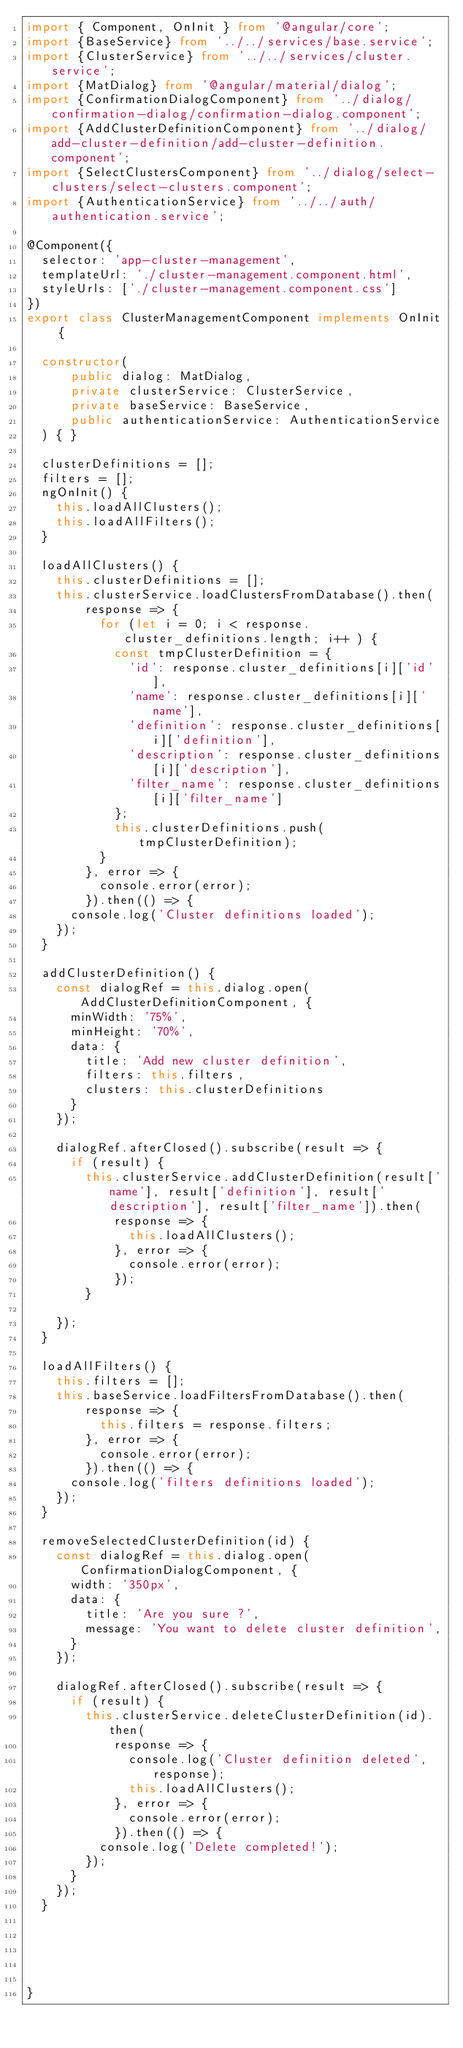<code> <loc_0><loc_0><loc_500><loc_500><_TypeScript_>import { Component, OnInit } from '@angular/core';
import {BaseService} from '../../services/base.service';
import {ClusterService} from '../../services/cluster.service';
import {MatDialog} from '@angular/material/dialog';
import {ConfirmationDialogComponent} from '../dialog/confirmation-dialog/confirmation-dialog.component';
import {AddClusterDefinitionComponent} from '../dialog/add-cluster-definition/add-cluster-definition.component';
import {SelectClustersComponent} from '../dialog/select-clusters/select-clusters.component';
import {AuthenticationService} from '../../auth/authentication.service';

@Component({
  selector: 'app-cluster-management',
  templateUrl: './cluster-management.component.html',
  styleUrls: ['./cluster-management.component.css']
})
export class ClusterManagementComponent implements OnInit {

  constructor(
      public dialog: MatDialog,
      private clusterService: ClusterService,
      private baseService: BaseService,
      public authenticationService: AuthenticationService
  ) { }

  clusterDefinitions = [];
  filters = [];
  ngOnInit() {
    this.loadAllClusters();
    this.loadAllFilters();
  }

  loadAllClusters() {
    this.clusterDefinitions = [];
    this.clusterService.loadClustersFromDatabase().then(
        response => {
          for (let i = 0; i < response.cluster_definitions.length; i++ ) {
            const tmpClusterDefinition = {
              'id': response.cluster_definitions[i]['id'],
              'name': response.cluster_definitions[i]['name'],
              'definition': response.cluster_definitions[i]['definition'],
              'description': response.cluster_definitions[i]['description'],
              'filter_name': response.cluster_definitions[i]['filter_name']
            };
            this.clusterDefinitions.push(tmpClusterDefinition);
          }
        }, error => {
          console.error(error);
        }).then(() => {
      console.log('Cluster definitions loaded');
    });
  }

  addClusterDefinition() {
    const dialogRef = this.dialog.open(AddClusterDefinitionComponent, {
      minWidth: '75%',
      minHeight: '70%',
      data: {
        title: 'Add new cluster definition',
        filters: this.filters,
        clusters: this.clusterDefinitions
      }
    });

    dialogRef.afterClosed().subscribe(result => {
      if (result) {
        this.clusterService.addClusterDefinition(result['name'], result['definition'], result['description'], result['filter_name']).then(
            response => {
              this.loadAllClusters();
            }, error => {
              console.error(error);
            });
        }

    });
  }

  loadAllFilters() {
    this.filters = [];
    this.baseService.loadFiltersFromDatabase().then(
        response => {
          this.filters = response.filters;
        }, error => {
          console.error(error);
        }).then(() => {
      console.log('filters definitions loaded');
    });
  }

  removeSelectedClusterDefinition(id) {
    const dialogRef = this.dialog.open(ConfirmationDialogComponent, {
      width: '350px',
      data: {
        title: 'Are you sure ?',
        message: 'You want to delete cluster definition',
      }
    });

    dialogRef.afterClosed().subscribe(result => {
      if (result) {
        this.clusterService.deleteClusterDefinition(id).then(
            response => {
              console.log('Cluster definition deleted', response);
              this.loadAllClusters();
            }, error => {
              console.error(error);
            }).then(() => {
          console.log('Delete completed!');
        });
      }
    });
  }





}
</code> 